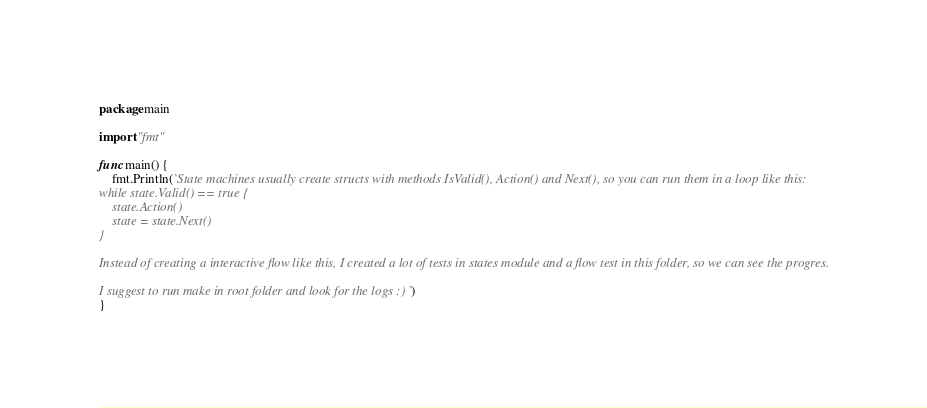Convert code to text. <code><loc_0><loc_0><loc_500><loc_500><_Go_>package main

import "fmt"

func main() {
	fmt.Println(`State machines usually create structs with methods IsValid(), Action() and Next(), so you can run them in a loop like this:
while state.Valid() == true {
    state.Action()
    state = state.Next()
}

Instead of creating a interactive flow like this, I created a lot of tests in states module and a flow test in this folder, so we can see the progres.

I suggest to run make in root folder and look for the logs :) `)
}
</code> 